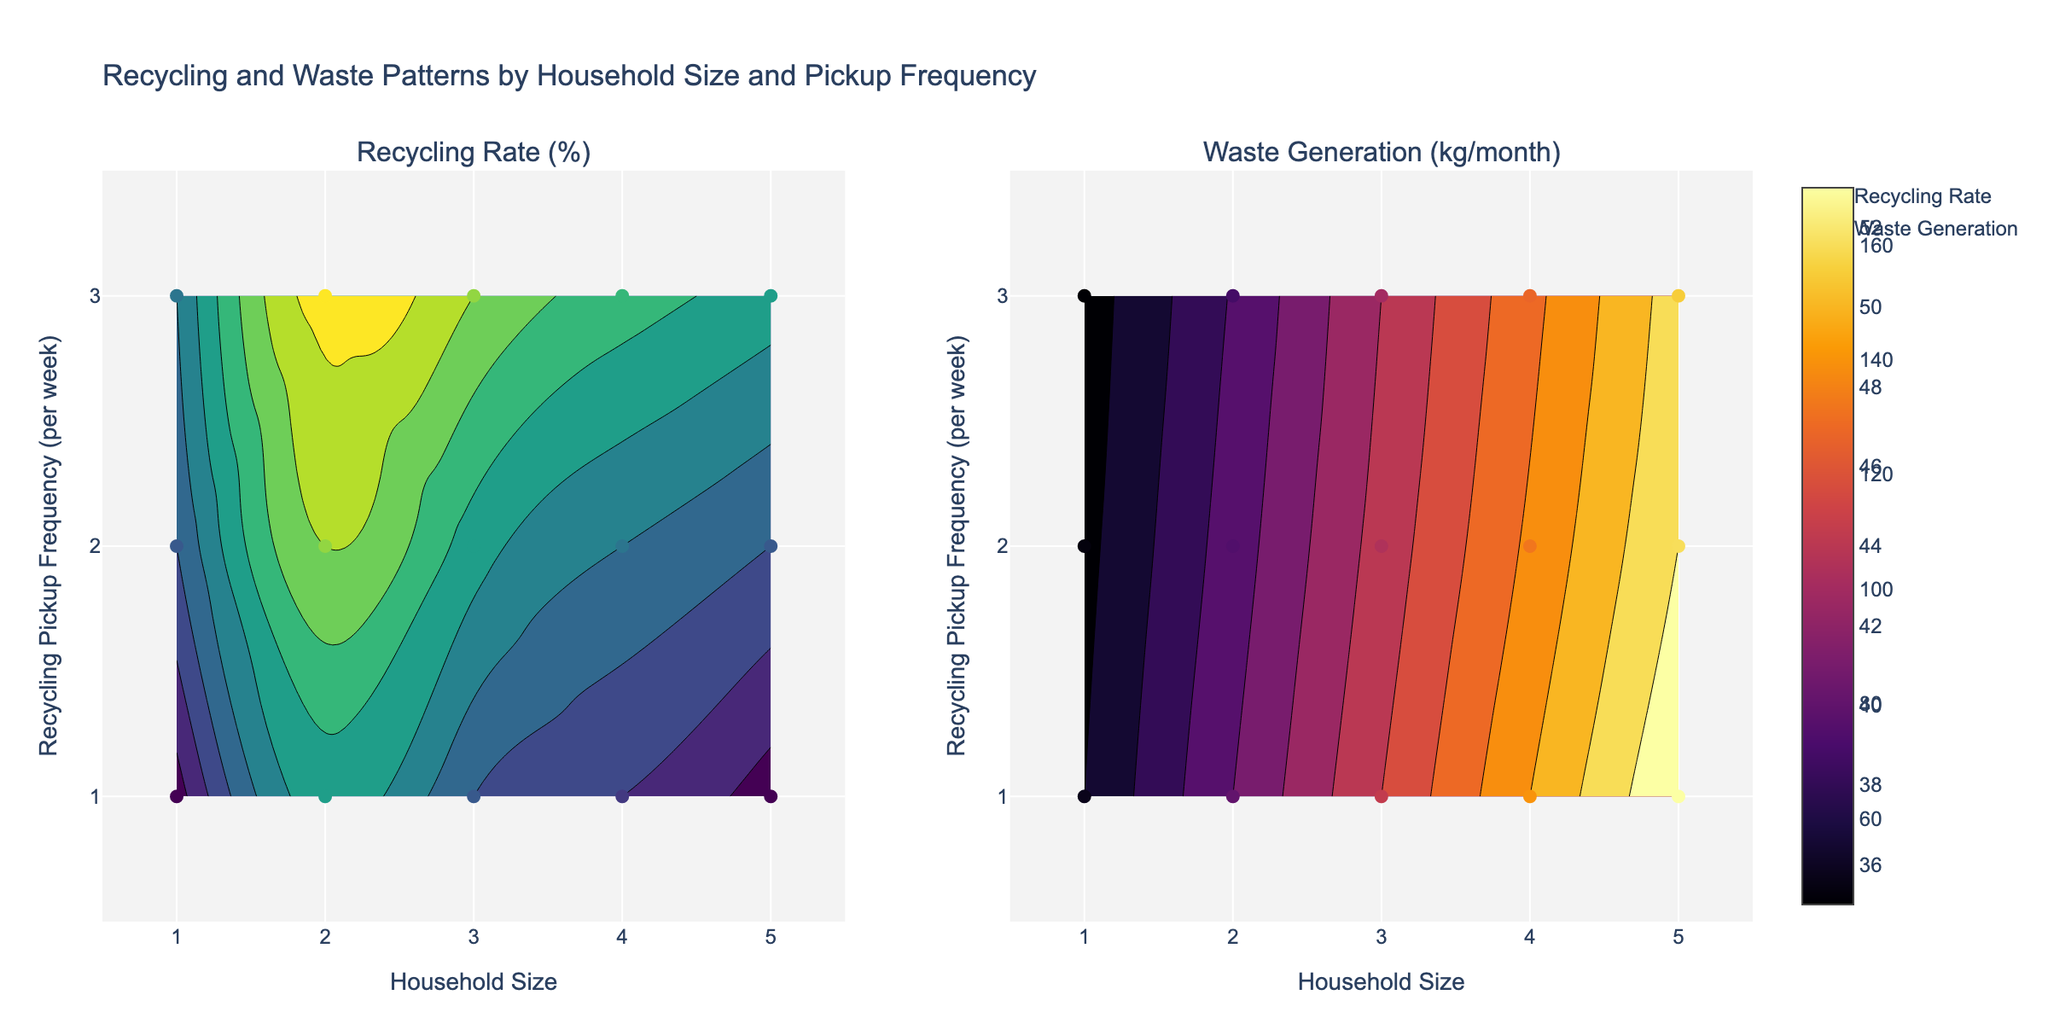What's the title of the figure? The title is displayed at the top of the figure. It states, "Recycling and Waste Patterns by Household Size and Pickup Frequency."
Answer: Recycling and Waste Patterns by Household Size and Pickup Frequency How many subplots are there in the figure? The figure has two subplots as indicated by the two side-by-side plots.
Answer: Two What are the x-axis and y-axis labels on the plot? The x-axis is labeled "Household Size" and the y-axis is labeled "Recycling Pickup Frequency (per week)."
Answer: Household Size and Recycling Pickup Frequency (per week) Which household size has the highest recycling rate for 2 pickups per week? Look at the recycling rate subplot, find 2 pickups per week on the y-axis and identify the highest recycling rate among the different household sizes.
Answer: 2 Which data point represents the lowest waste generation for 1 pickup per week? In the waste generation subplot, find 1 pickup per week on the y-axis and check the waste generation values across household sizes. The lowest waste generation is at Household Size = 1.
Answer: Household Size = 1 Does an increase in pickup frequency generally lead to an increase in recycling rate? Observe the recycling rate subplot and compare the recycling rates for different pickup frequencies across various household sizes.
Answer: Yes Which household size shows the largest decrease in waste generation when the pickup frequency increases from 1 to 2 times per week? In the waste generation subplot, compare the waste generation values for 1 and 2 pickups per week for each household size, and calculate the differences.
Answer: 5 What is the average recycling rate for a household size of 3 across all pickup frequencies? In the recycling rate subplot, find the recycling rates for household size 3 at each pickup frequency (40%, 45%, 50%). Calculate (40 + 45 + 50)/3.
Answer: 45% Is there a trend between household size and waste generation? Observe the waste generation subplot to see if larger household sizes generally produce more waste.
Answer: Yes, larger household sizes generate more waste 